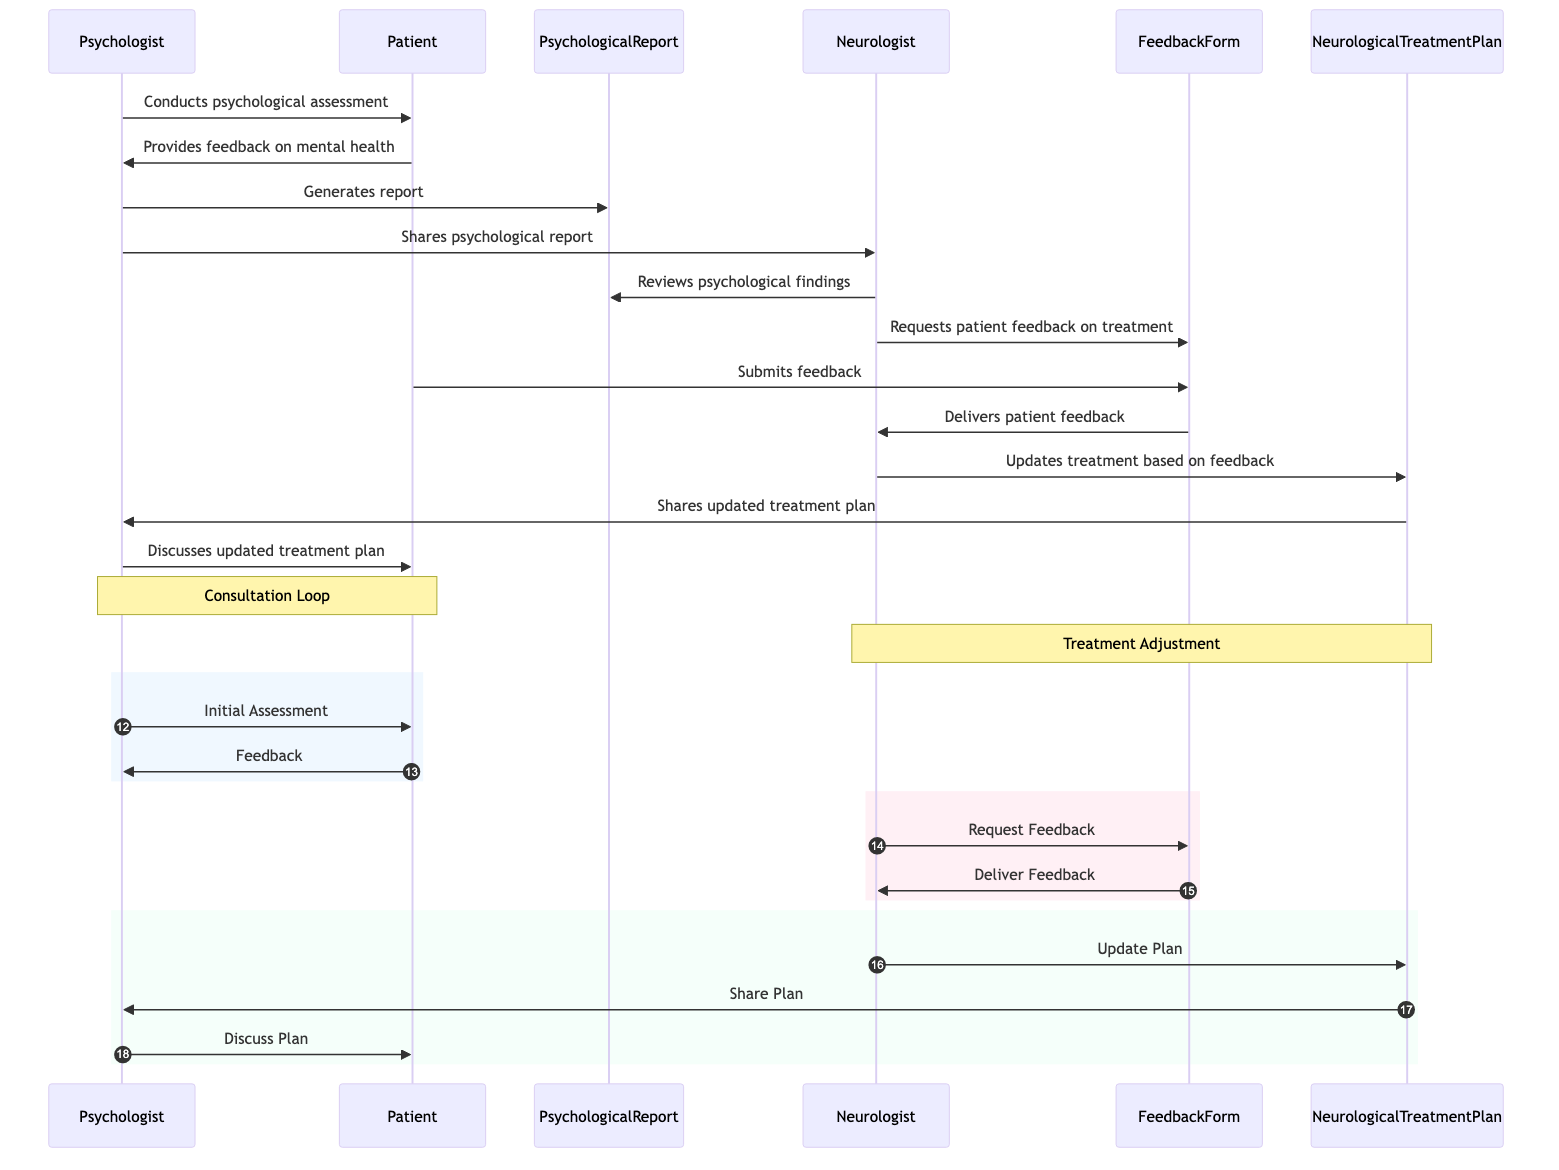What is the first action by the Psychologist? The diagram indicates that the first action taken by the Psychologist is to conduct a psychological assessment with the Patient, which initiates the sequence.
Answer: Conducts psychological assessment How many objects are involved in the consultation loop? The diagram features three distinct objects in the consultation loop: the Psychological Report, the Feedback Form, and the Neurological Treatment Plan.
Answer: Three What action does the Neurologist take after reviewing the Psychological findings? After reviewing the psychological findings from the Psychological Report, the Neurologist requests patient feedback on treatment through the Feedback Form.
Answer: Requests patient feedback on treatment Which actor shares the updated treatment plan? The Neurologist shares the updated treatment plan with the Psychologist after updating it based on the feedback received from the patient.
Answer: Neurologist What is the final action in the sequence between the Psychologist and Patient? The final action in the sequence is the Psychologist discussing the updated treatment plan with the Patient, concluding the feedback loop.
Answer: Discusses updated treatment plan What do the Feedback Form and Neurologist represent in terms of interaction? The Feedback Form acts as a medium that collects feedback from the Patient and then delivers that feedback to the Neurologist for review and action.
Answer: Medium for feedback collection How many interactions does the Patient have with the Feedback Form? The Patient interacts with the Feedback Form two times: once when the Neurologist requests feedback and once when the Patient submits the feedback.
Answer: Two interactions What denotes the consultation loop in the diagram? The consultation loop between the Psychologist and Patient is denoted by a note over their corresponding interaction actions in the sequence, indicating a continuous assessment process.
Answer: Consultation Loop Which actor initiates the process of generating a Psychological Report? The process of generating the Psychological Report is initiated by the Psychologist after receiving feedback from the Patient.
Answer: Psychologist 